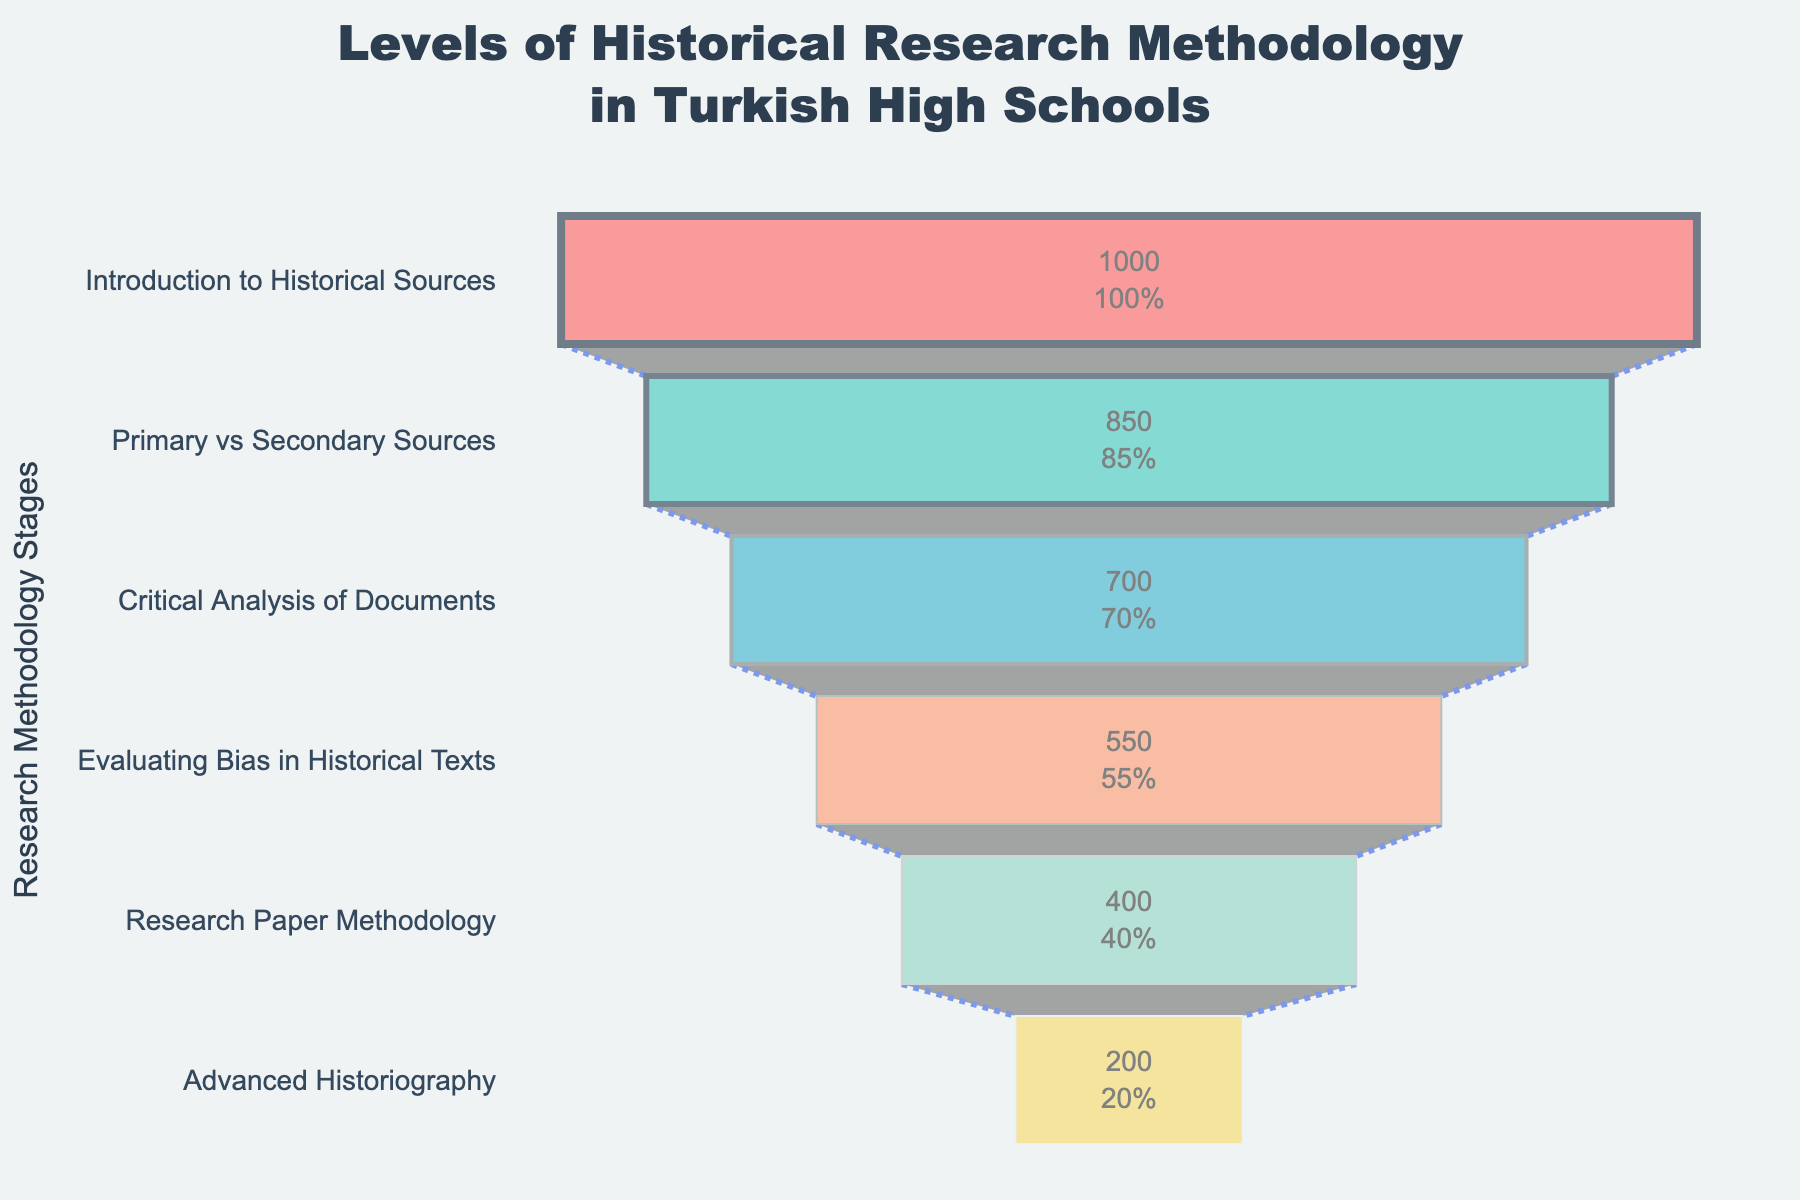What is the title of the funnel chart? The title is located at the top of the chart, easily identifiable by the font size and position.
Answer: Levels of Historical Research Methodology in Turkish High Schools How many stages are listed in the funnel chart? By counting the different stages listed on the Y-axis, which represent various levels of historical research methodology, we can determine the total number.
Answer: 6 Which stage has the highest number of students? Look for the segment with the largest width at the top of the funnel chart, indicating the highest number of students.
Answer: Introduction to Historical Sources What is the percentage of students remaining after the "Primary vs Secondary Sources" stage? It is written inside the funnel chart segment related to this stage, indicating the percentage of students who progressed compared to the initial stage.
Answer: 85% How many students advanced to the "Evaluating Bias in Historical Texts" stage? Check the number written inside the segment of the funnel chart representing this specific stage.
Answer: 550 What is the difference in the number of students between the "Critical Analysis of Documents" and the "Research Paper Methodology" stages? Subtract the number of students in the "Research Paper Methodology" stage from the number in the "Critical Analysis of Documents" stage to find the difference.
Answer: 300 Which stage sees the biggest drop in the number of students compared to the previous stage? To find this, calculate the difference between successive stages, and identify the pair with the largest drop.
Answer: Evaluating Bias in Historical Texts (150 students drop from the previous stage) How much does the number of students decrease from the "Introduction to Historical Sources" to the "Primary vs Secondary Sources" stage? Subtract the number of students in "Primary vs Secondary Sources" from "Introduction to Historical Sources".
Answer: 150 What percentage of the initial students reach the "Advanced Historiography" stage? This percentage will be provided inside the chart's segment representing the "Advanced Historiography" stage, showing the percentage relative to the initial stage.
Answer: 20% Which stage has a yellow segment in the funnel chart? Identify the color code used in the segments, where yellow appears to locate this specific stage.
Answer: Advanced Historiography 